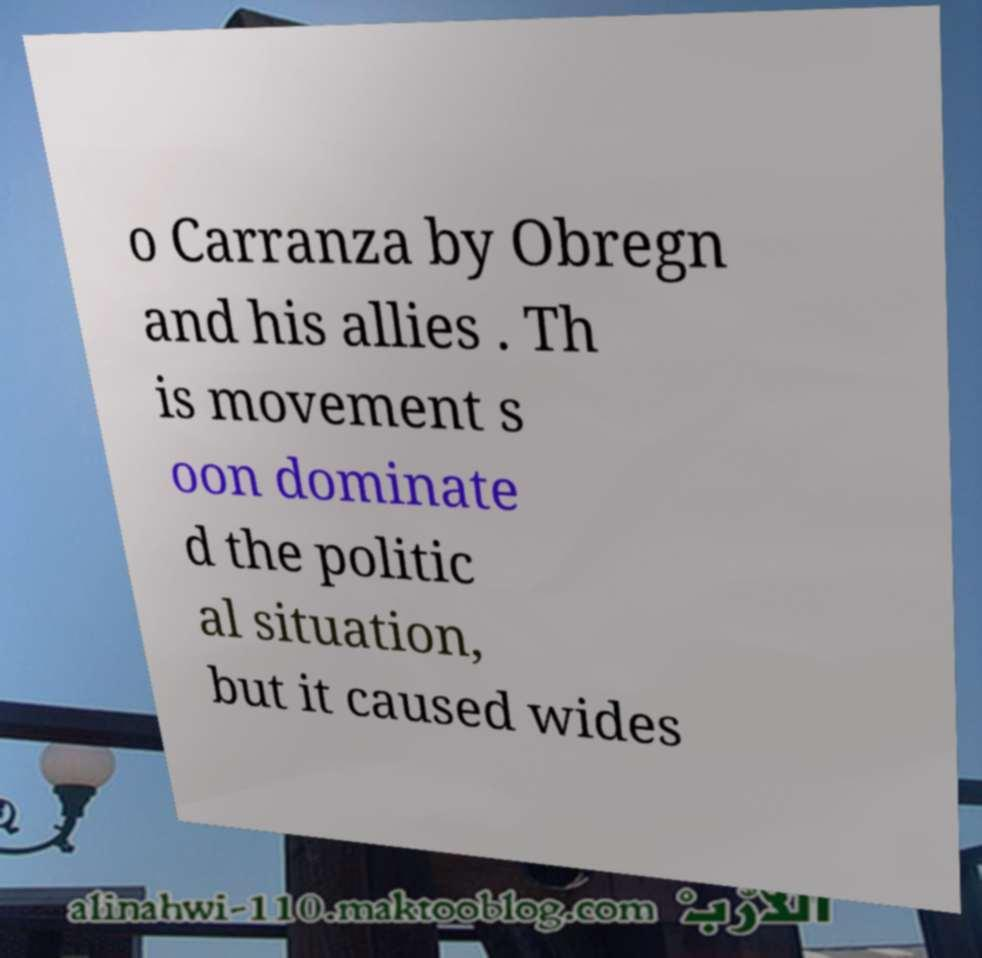I need the written content from this picture converted into text. Can you do that? o Carranza by Obregn and his allies . Th is movement s oon dominate d the politic al situation, but it caused wides 